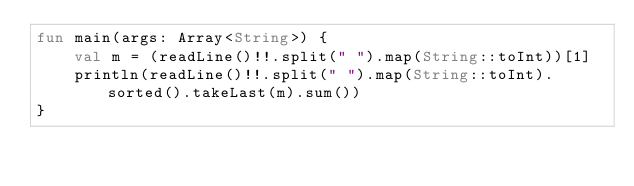Convert code to text. <code><loc_0><loc_0><loc_500><loc_500><_Kotlin_>fun main(args: Array<String>) {
    val m = (readLine()!!.split(" ").map(String::toInt))[1]
    println(readLine()!!.split(" ").map(String::toInt).sorted().takeLast(m).sum())
}</code> 